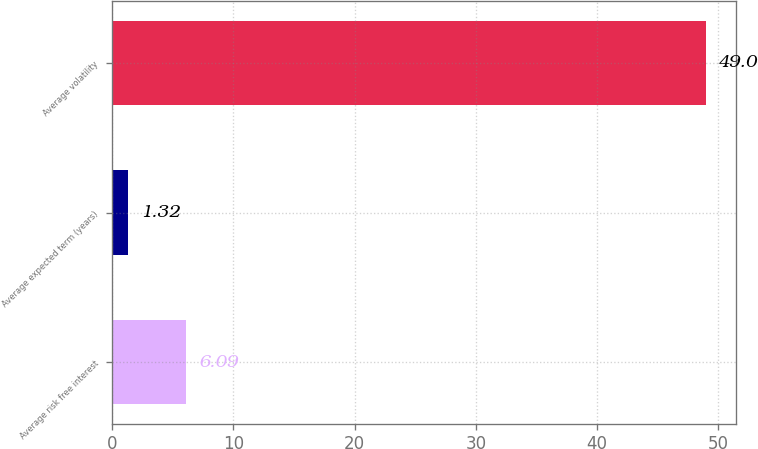<chart> <loc_0><loc_0><loc_500><loc_500><bar_chart><fcel>Average risk free interest<fcel>Average expected term (years)<fcel>Average volatility<nl><fcel>6.09<fcel>1.32<fcel>49<nl></chart> 